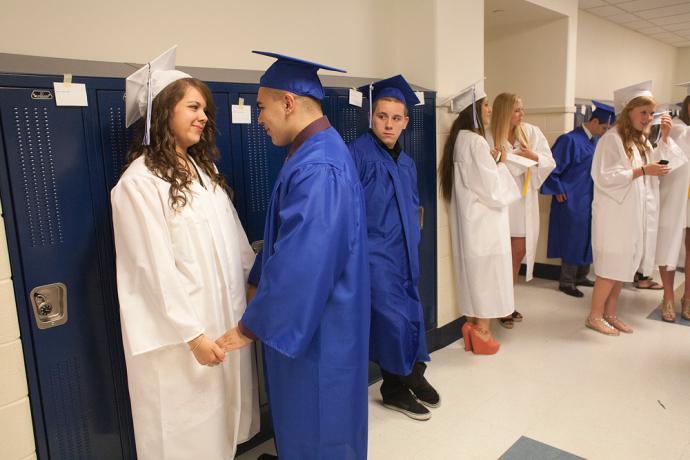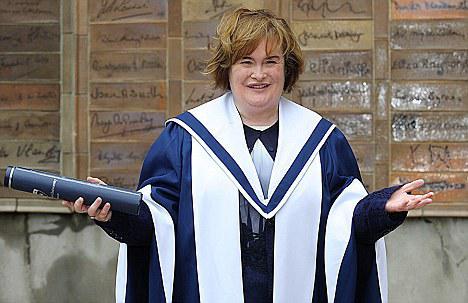The first image is the image on the left, the second image is the image on the right. Assess this claim about the two images: "The left image contains no more than two humans.". Correct or not? Answer yes or no. No. The first image is the image on the left, the second image is the image on the right. Given the left and right images, does the statement "One image includes at least one male in a royal blue graduation gown and cap, and the other image contains no male graduates." hold true? Answer yes or no. Yes. 